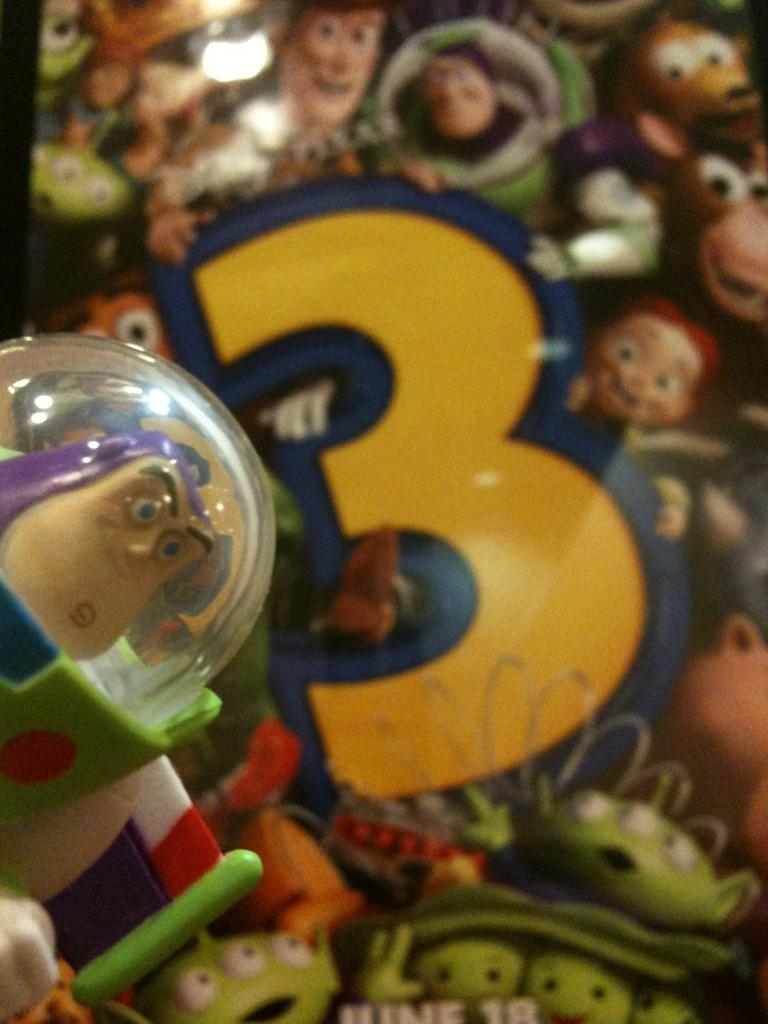What objects can be seen on the table in the image? There are toys on the table in the image. What can be seen in the background of the image? There is a poster of a film in the background of the image. Is the queen present in the image, sitting on her throne? There is no queen or throne present in the image; it features toys on a table and a film poster in the background. Can you see any water in the image? There is no water visible in the image. 